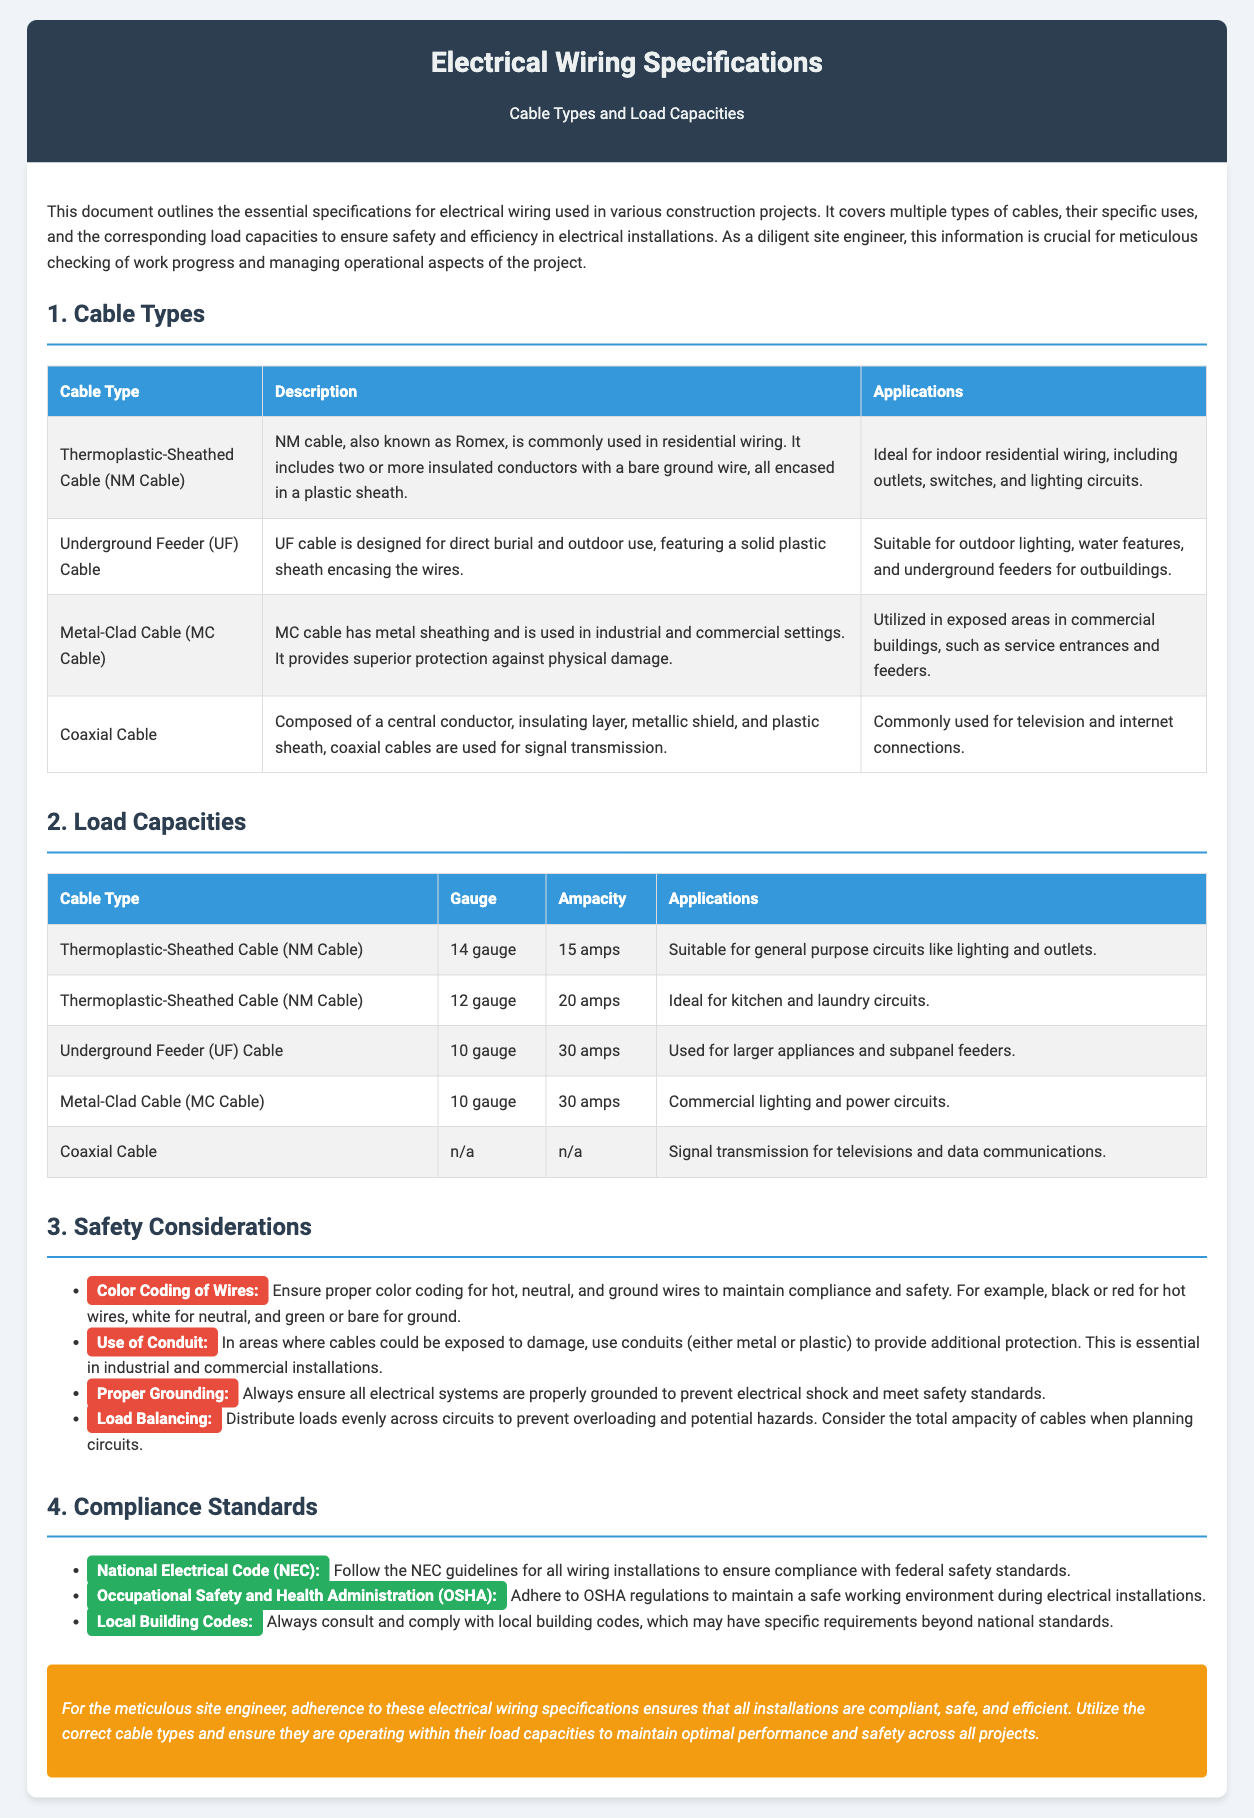What is NM Cable commonly used for? NM Cable is ideal for indoor residential wiring, including outlets, switches, and lighting circuits.
Answer: Indoor residential wiring What is the ampacity of 12 gauge NM Cable? The document states that 12 gauge NM Cable has an ampacity of 20 amps.
Answer: 20 amps Which cable type is designed for direct burial? The document specifies that Underground Feeder (UF) Cable is designed for direct burial and outdoor use.
Answer: Underground Feeder (UF) Cable What safety consideration emphasizes the use of conduits? The point about the use of conduits under safety considerations highlights the need for protection in areas where cables could be exposed to damage.
Answer: Use of Conduit According to the compliance standards, what federal code must be followed for wiring installations? The document mentions that the National Electrical Code (NEC) guidelines must be followed for all wiring installations.
Answer: National Electrical Code (NEC) What is the ampacity of 10 gauge UF Cable? The document indicates that 10 gauge UF Cable has an ampacity of 30 amps.
Answer: 30 amps In what applications is coaxial cable commonly used? Coaxial cable is commonly used for television and internet connections.
Answer: Television and internet connections What is the gauge of Thermoplastic-Sheathed Cable (NM Cable) suitable for general-purpose circuits? The document states that 14 gauge is suitable for general-purpose circuits using NM Cable.
Answer: 14 gauge 